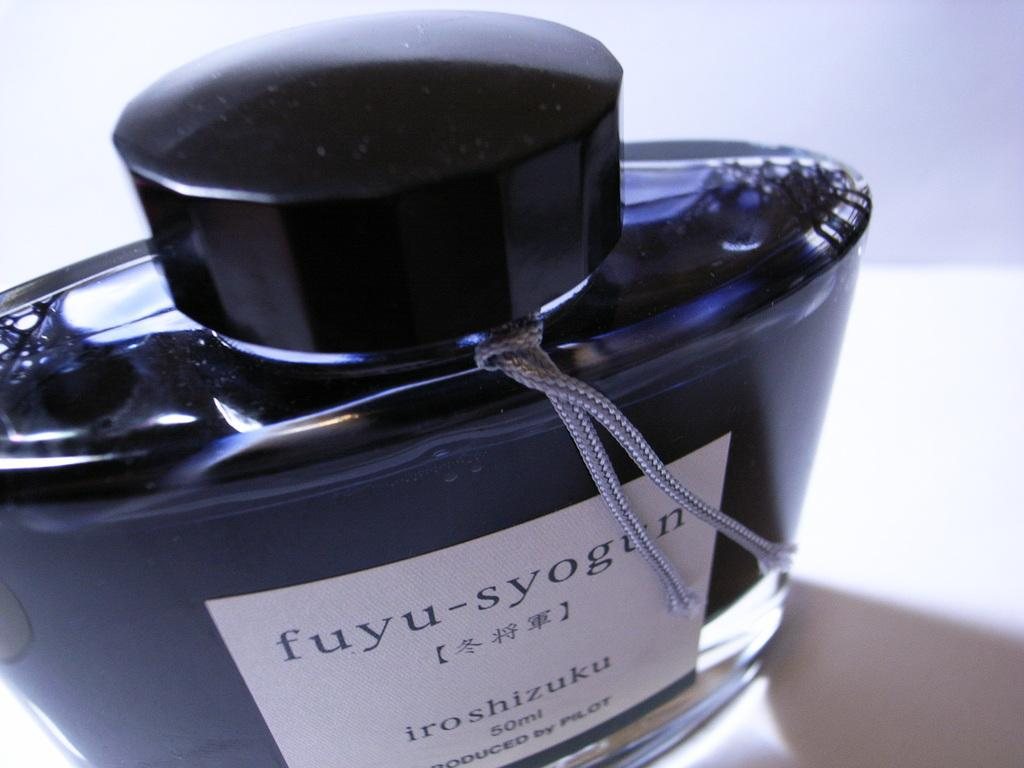<image>
Render a clear and concise summary of the photo. A bottle of fuyu-syogun has a very sleek and elegant appearance and has been shot at an interesting angle. 